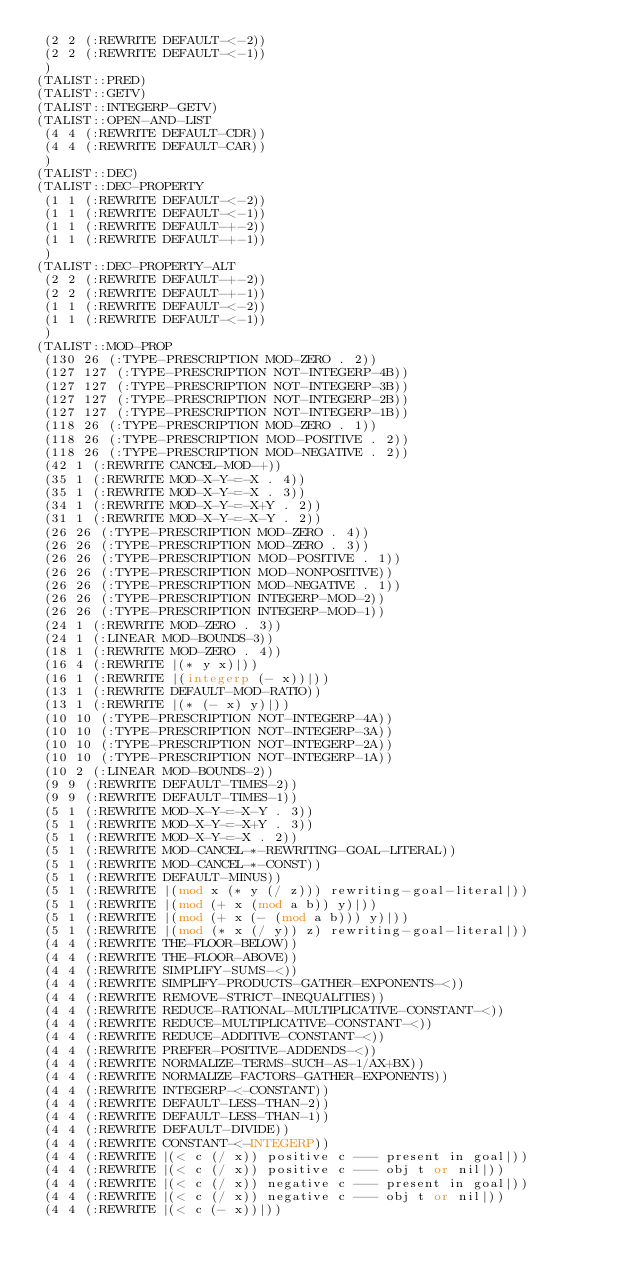<code> <loc_0><loc_0><loc_500><loc_500><_Lisp_> (2 2 (:REWRITE DEFAULT-<-2))
 (2 2 (:REWRITE DEFAULT-<-1))
 )
(TALIST::PRED)
(TALIST::GETV)
(TALIST::INTEGERP-GETV)
(TALIST::OPEN-AND-LIST
 (4 4 (:REWRITE DEFAULT-CDR))
 (4 4 (:REWRITE DEFAULT-CAR))
 )
(TALIST::DEC)
(TALIST::DEC-PROPERTY
 (1 1 (:REWRITE DEFAULT-<-2))
 (1 1 (:REWRITE DEFAULT-<-1))
 (1 1 (:REWRITE DEFAULT-+-2))
 (1 1 (:REWRITE DEFAULT-+-1))
 )
(TALIST::DEC-PROPERTY-ALT
 (2 2 (:REWRITE DEFAULT-+-2))
 (2 2 (:REWRITE DEFAULT-+-1))
 (1 1 (:REWRITE DEFAULT-<-2))
 (1 1 (:REWRITE DEFAULT-<-1))
 )
(TALIST::MOD-PROP
 (130 26 (:TYPE-PRESCRIPTION MOD-ZERO . 2))
 (127 127 (:TYPE-PRESCRIPTION NOT-INTEGERP-4B))
 (127 127 (:TYPE-PRESCRIPTION NOT-INTEGERP-3B))
 (127 127 (:TYPE-PRESCRIPTION NOT-INTEGERP-2B))
 (127 127 (:TYPE-PRESCRIPTION NOT-INTEGERP-1B))
 (118 26 (:TYPE-PRESCRIPTION MOD-ZERO . 1))
 (118 26 (:TYPE-PRESCRIPTION MOD-POSITIVE . 2))
 (118 26 (:TYPE-PRESCRIPTION MOD-NEGATIVE . 2))
 (42 1 (:REWRITE CANCEL-MOD-+))
 (35 1 (:REWRITE MOD-X-Y-=-X . 4))
 (35 1 (:REWRITE MOD-X-Y-=-X . 3))
 (34 1 (:REWRITE MOD-X-Y-=-X+Y . 2))
 (31 1 (:REWRITE MOD-X-Y-=-X-Y . 2))
 (26 26 (:TYPE-PRESCRIPTION MOD-ZERO . 4))
 (26 26 (:TYPE-PRESCRIPTION MOD-ZERO . 3))
 (26 26 (:TYPE-PRESCRIPTION MOD-POSITIVE . 1))
 (26 26 (:TYPE-PRESCRIPTION MOD-NONPOSITIVE))
 (26 26 (:TYPE-PRESCRIPTION MOD-NEGATIVE . 1))
 (26 26 (:TYPE-PRESCRIPTION INTEGERP-MOD-2))
 (26 26 (:TYPE-PRESCRIPTION INTEGERP-MOD-1))
 (24 1 (:REWRITE MOD-ZERO . 3))
 (24 1 (:LINEAR MOD-BOUNDS-3))
 (18 1 (:REWRITE MOD-ZERO . 4))
 (16 4 (:REWRITE |(* y x)|))
 (16 1 (:REWRITE |(integerp (- x))|))
 (13 1 (:REWRITE DEFAULT-MOD-RATIO))
 (13 1 (:REWRITE |(* (- x) y)|))
 (10 10 (:TYPE-PRESCRIPTION NOT-INTEGERP-4A))
 (10 10 (:TYPE-PRESCRIPTION NOT-INTEGERP-3A))
 (10 10 (:TYPE-PRESCRIPTION NOT-INTEGERP-2A))
 (10 10 (:TYPE-PRESCRIPTION NOT-INTEGERP-1A))
 (10 2 (:LINEAR MOD-BOUNDS-2))
 (9 9 (:REWRITE DEFAULT-TIMES-2))
 (9 9 (:REWRITE DEFAULT-TIMES-1))
 (5 1 (:REWRITE MOD-X-Y-=-X-Y . 3))
 (5 1 (:REWRITE MOD-X-Y-=-X+Y . 3))
 (5 1 (:REWRITE MOD-X-Y-=-X . 2))
 (5 1 (:REWRITE MOD-CANCEL-*-REWRITING-GOAL-LITERAL))
 (5 1 (:REWRITE MOD-CANCEL-*-CONST))
 (5 1 (:REWRITE DEFAULT-MINUS))
 (5 1 (:REWRITE |(mod x (* y (/ z))) rewriting-goal-literal|))
 (5 1 (:REWRITE |(mod (+ x (mod a b)) y)|))
 (5 1 (:REWRITE |(mod (+ x (- (mod a b))) y)|))
 (5 1 (:REWRITE |(mod (* x (/ y)) z) rewriting-goal-literal|))
 (4 4 (:REWRITE THE-FLOOR-BELOW))
 (4 4 (:REWRITE THE-FLOOR-ABOVE))
 (4 4 (:REWRITE SIMPLIFY-SUMS-<))
 (4 4 (:REWRITE SIMPLIFY-PRODUCTS-GATHER-EXPONENTS-<))
 (4 4 (:REWRITE REMOVE-STRICT-INEQUALITIES))
 (4 4 (:REWRITE REDUCE-RATIONAL-MULTIPLICATIVE-CONSTANT-<))
 (4 4 (:REWRITE REDUCE-MULTIPLICATIVE-CONSTANT-<))
 (4 4 (:REWRITE REDUCE-ADDITIVE-CONSTANT-<))
 (4 4 (:REWRITE PREFER-POSITIVE-ADDENDS-<))
 (4 4 (:REWRITE NORMALIZE-TERMS-SUCH-AS-1/AX+BX))
 (4 4 (:REWRITE NORMALIZE-FACTORS-GATHER-EXPONENTS))
 (4 4 (:REWRITE INTEGERP-<-CONSTANT))
 (4 4 (:REWRITE DEFAULT-LESS-THAN-2))
 (4 4 (:REWRITE DEFAULT-LESS-THAN-1))
 (4 4 (:REWRITE DEFAULT-DIVIDE))
 (4 4 (:REWRITE CONSTANT-<-INTEGERP))
 (4 4 (:REWRITE |(< c (/ x)) positive c --- present in goal|))
 (4 4 (:REWRITE |(< c (/ x)) positive c --- obj t or nil|))
 (4 4 (:REWRITE |(< c (/ x)) negative c --- present in goal|))
 (4 4 (:REWRITE |(< c (/ x)) negative c --- obj t or nil|))
 (4 4 (:REWRITE |(< c (- x))|))</code> 